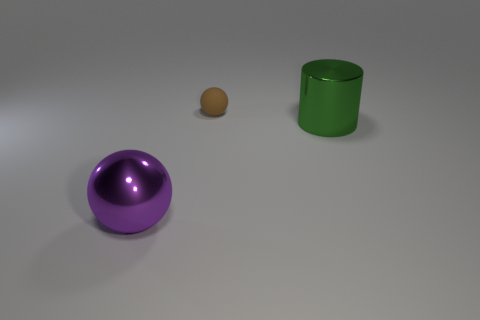Add 2 brown rubber objects. How many objects exist? 5 Subtract all balls. How many objects are left? 1 Add 2 purple objects. How many purple objects exist? 3 Subtract 0 yellow cylinders. How many objects are left? 3 Subtract all big things. Subtract all brown balls. How many objects are left? 0 Add 3 small things. How many small things are left? 4 